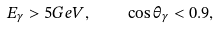Convert formula to latex. <formula><loc_0><loc_0><loc_500><loc_500>E _ { \gamma } > 5 { G e V } , \quad \cos \theta _ { \gamma } < 0 . 9 ,</formula> 